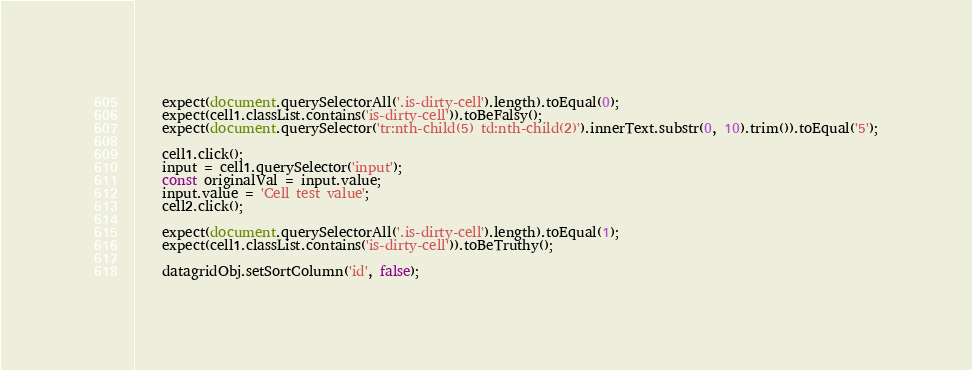<code> <loc_0><loc_0><loc_500><loc_500><_JavaScript_>
    expect(document.querySelectorAll('.is-dirty-cell').length).toEqual(0);
    expect(cell1.classList.contains('is-dirty-cell')).toBeFalsy();
    expect(document.querySelector('tr:nth-child(5) td:nth-child(2)').innerText.substr(0, 10).trim()).toEqual('5');

    cell1.click();
    input = cell1.querySelector('input');
    const originalVal = input.value;
    input.value = 'Cell test value';
    cell2.click();

    expect(document.querySelectorAll('.is-dirty-cell').length).toEqual(1);
    expect(cell1.classList.contains('is-dirty-cell')).toBeTruthy();

    datagridObj.setSortColumn('id', false);
</code> 